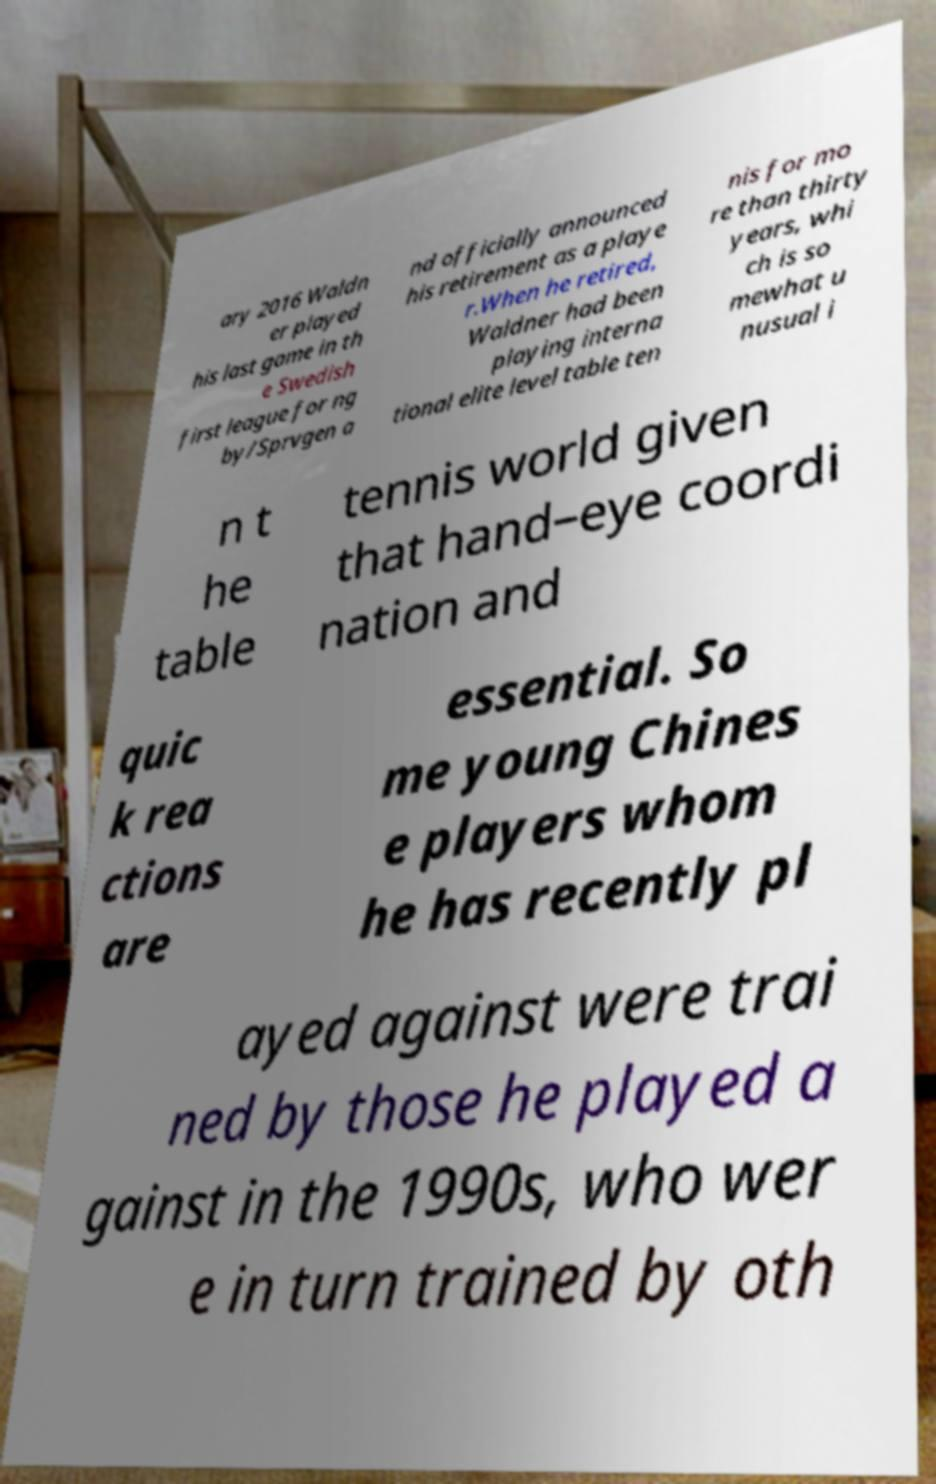Could you extract and type out the text from this image? ary 2016 Waldn er played his last game in th e Swedish first league for ng by/Sprvgen a nd officially announced his retirement as a playe r.When he retired, Waldner had been playing interna tional elite level table ten nis for mo re than thirty years, whi ch is so mewhat u nusual i n t he table tennis world given that hand–eye coordi nation and quic k rea ctions are essential. So me young Chines e players whom he has recently pl ayed against were trai ned by those he played a gainst in the 1990s, who wer e in turn trained by oth 